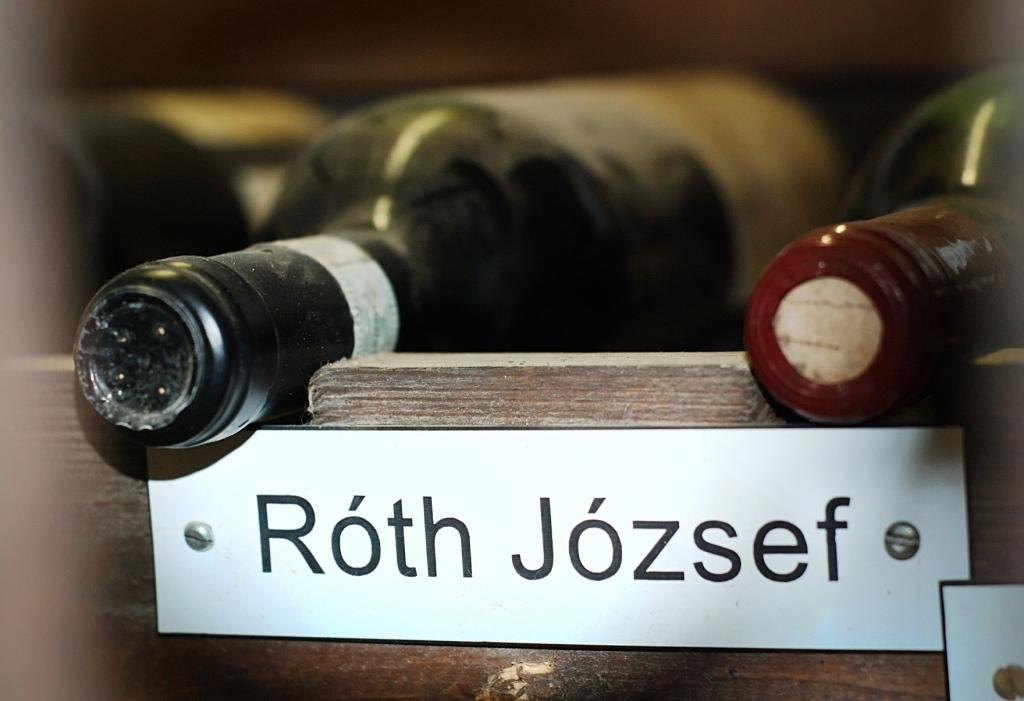<image>
Share a concise interpretation of the image provided. White name label that says Roth Jozsef on it. 